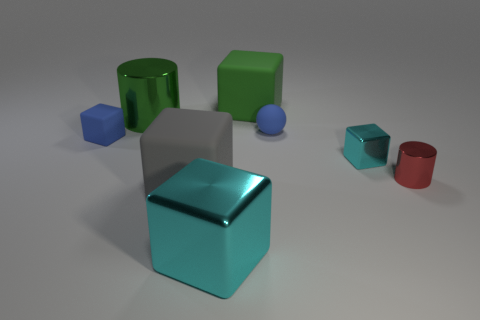Subtract all big gray rubber cubes. How many cubes are left? 4 Add 1 cyan metallic cubes. How many objects exist? 9 Subtract all brown spheres. How many cyan blocks are left? 2 Subtract all cyan blocks. How many blocks are left? 3 Subtract 2 cubes. How many cubes are left? 3 Subtract all balls. How many objects are left? 7 Subtract all blue blocks. Subtract all gray spheres. How many blocks are left? 4 Subtract all red metallic cylinders. Subtract all small shiny blocks. How many objects are left? 6 Add 5 tiny cylinders. How many tiny cylinders are left? 6 Add 5 cyan metallic cubes. How many cyan metallic cubes exist? 7 